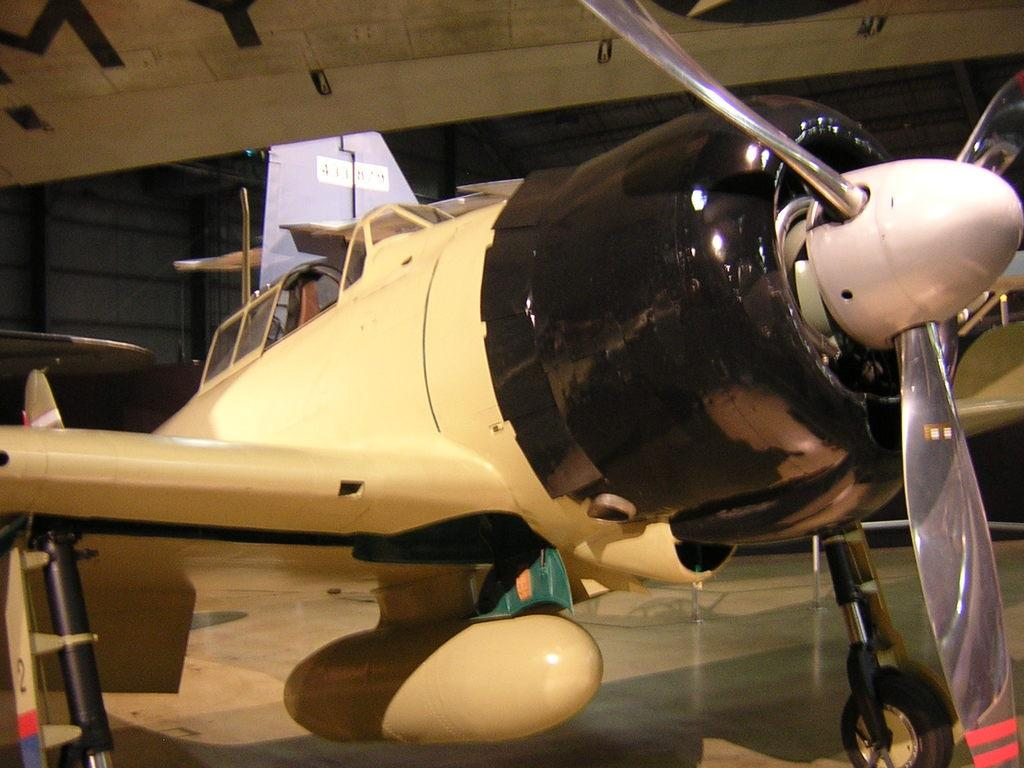What is the main subject of the image? The main subject of the image is an aircraft. Can you describe the location of the aircraft in the image? The aircraft is in the middle of the image. What else can be seen in the background of the image? There appears to be a shirt in the background of the image. What type of stew is being served on the aircraft in the image? There is no stew visible in the image, as it only features an aircraft and a shirt in the background. 